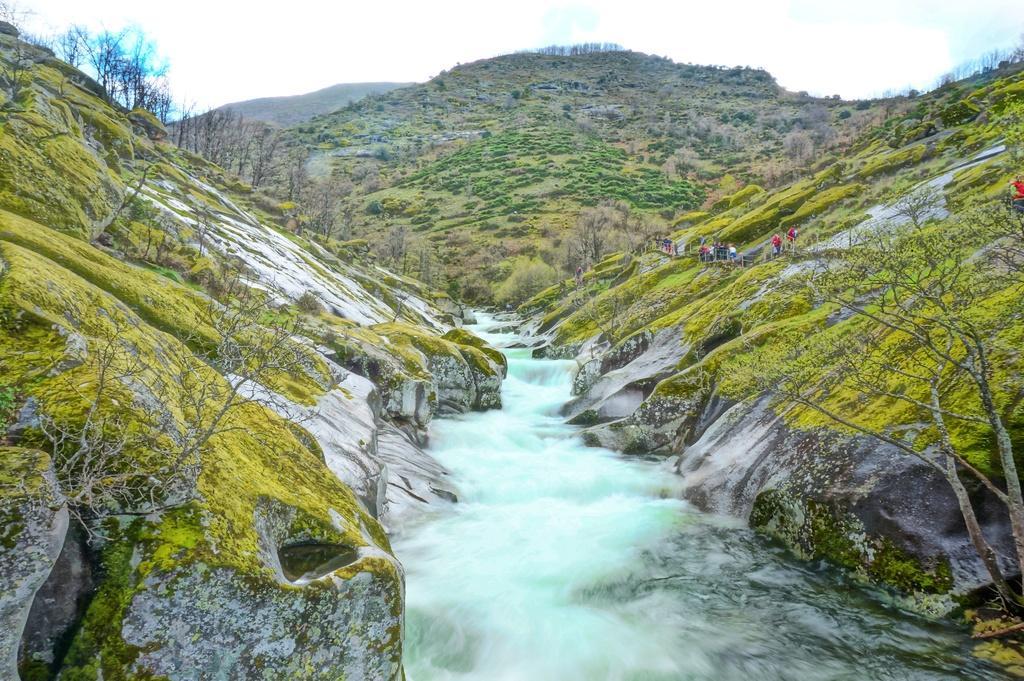Please provide a concise description of this image. In this image I can see water in the centre and on the both side of it I can see number of trees. On the right side of this image I can see number of people are standing. In the background I can see mountains and the sky. 